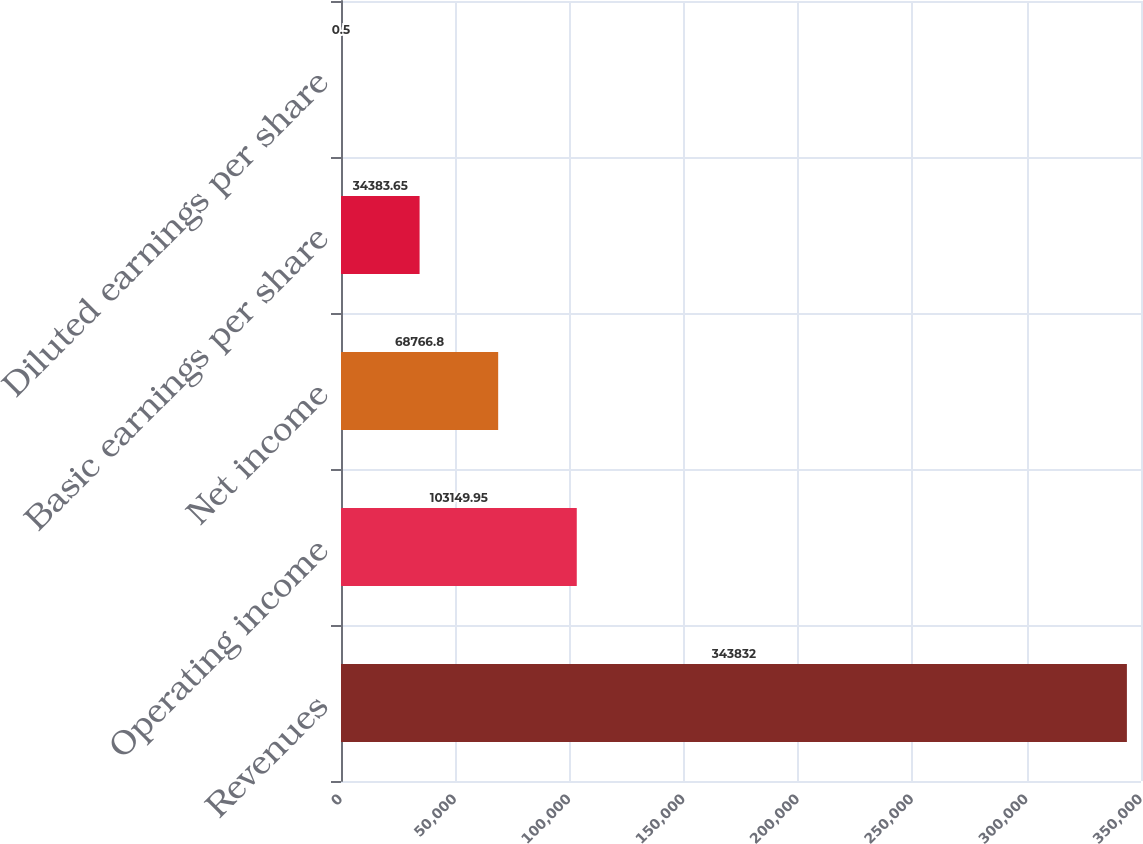Convert chart. <chart><loc_0><loc_0><loc_500><loc_500><bar_chart><fcel>Revenues<fcel>Operating income<fcel>Net income<fcel>Basic earnings per share<fcel>Diluted earnings per share<nl><fcel>343832<fcel>103150<fcel>68766.8<fcel>34383.7<fcel>0.5<nl></chart> 